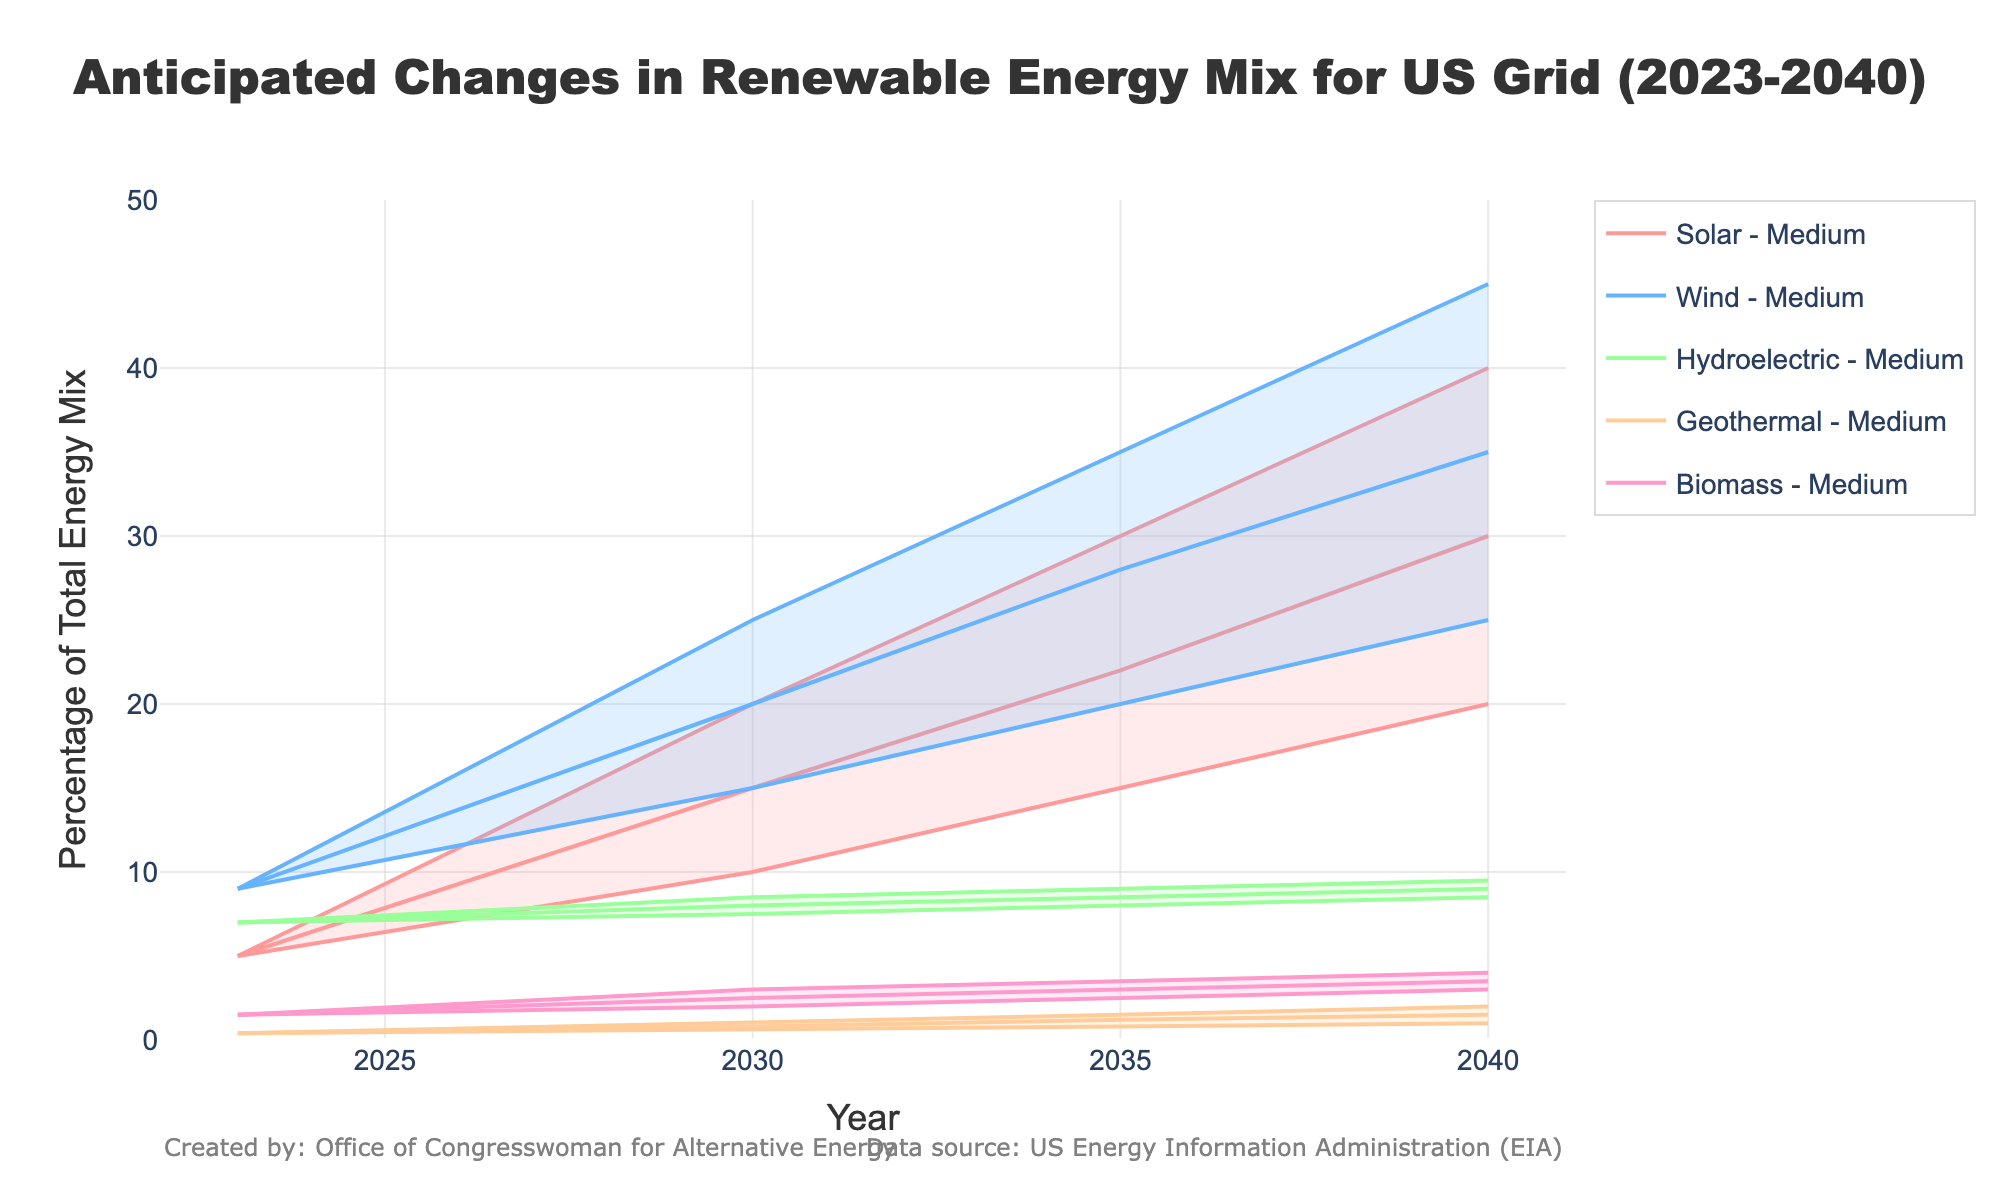What is the title of the figure? The title of the figure is usually displayed at the top of the chart. In this case, it is "Anticipated Changes in Renewable Energy Mix for US Grid (2023-2040)."
Answer: Anticipated Changes in Renewable Energy Mix for US Grid (2023-2040) What are the renewable energy sources represented in the figure? The renewable energy sources are typically indicated in the legend or the axis labels. Here, they are Solar, Wind, Hydroelectric, Geothermal, and Biomass.
Answer: Solar, Wind, Hydroelectric, Geothermal, Biomass What is the projected percentage of Solar energy in the High scenario for the year 2040? To find this, look at the High scenario data point for Solar energy in the year 2040. The chart shows that it's 40%.
Answer: 40% How does the percentage of Wind energy in the Medium scenario change from 2023 to 2040? Compare the percentages of Wind energy in the Medium scenario for the years 2023 and 2040. It starts at 9% in 2023 and increases to 35% in 2040. So, the percentage increases by 26%.
Answer: 26% Which renewable energy source is projected to have the smallest increase in the Low scenario from 2023 to 2040? Calculate the difference for each renewable energy source between 2023 and 2040 in the Low scenario. Geothermal increases from 0.4% to 1%, which is the smallest increase.
Answer: Geothermal In 2035, in the Medium scenario, what is the combined percentage of Solar, Wind, and Hydroelectric energy? Sum up the percentages of Solar, Wind, and Hydroelectric for the Medium scenario in 2035: 22% (Solar) + 28% (Wind) + 8.5% (Hydroelectric) = 58.5%.
Answer: 58.5% Which scenario shows the highest growth rate for Solar energy from 2023 to 2040? By comparing the growth rates across scenarios, we see that the High scenario shows Solar growing from 5% in 2023 to 40% in 2040, an increase of 35%, which is the highest growth rate.
Answer: High What is the median projected percentage of Hydroelectric energy in 2040 across all scenarios? Identify the percentage of Hydroelectric energy for the year 2040 across all scenarios: 8.5%, 9%, and 9.5%. The median value is 9%.
Answer: 9% Between 2023 and 2040, which renewable energy source shows most consistency in its percentage across all scenarios? Consistency can be assessed by evaluating the variation in projected values across different scenarios. Hydroelectric shows the least variation, staying close to 7-9.5% across all years and scenarios.
Answer: Hydroelectric 